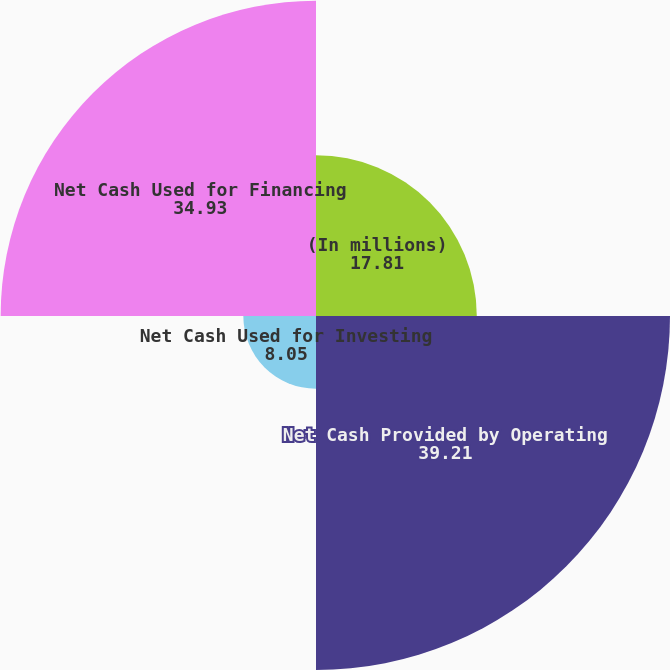<chart> <loc_0><loc_0><loc_500><loc_500><pie_chart><fcel>(In millions)<fcel>Net Cash Provided by Operating<fcel>Net Cash Used for Investing<fcel>Net Cash Used for Financing<nl><fcel>17.81%<fcel>39.21%<fcel>8.05%<fcel>34.93%<nl></chart> 